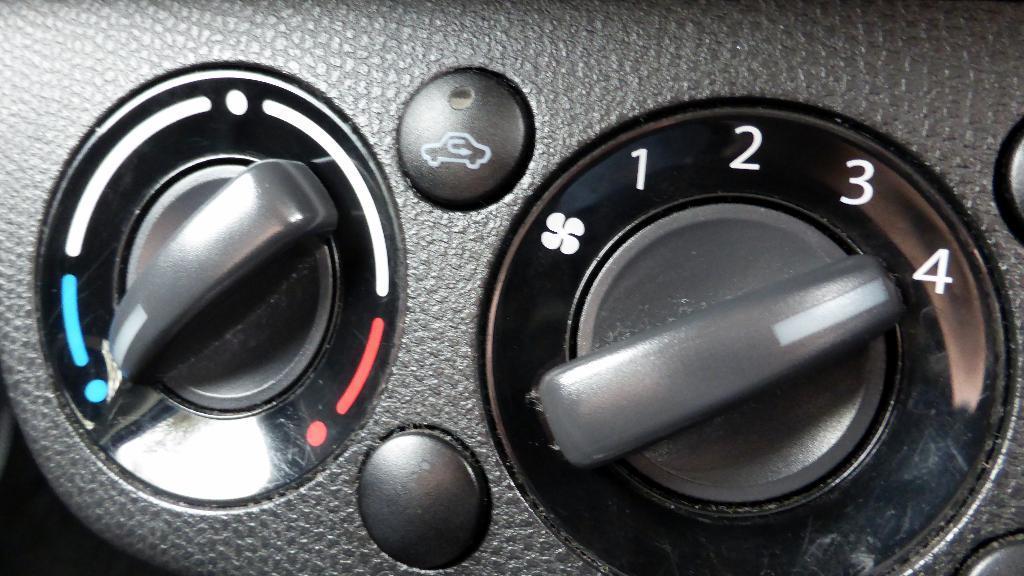How would you summarize this image in a sentence or two? In this image, we can see two controlling knobs and there are two black color buttons. 